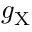<formula> <loc_0><loc_0><loc_500><loc_500>g _ { X }</formula> 